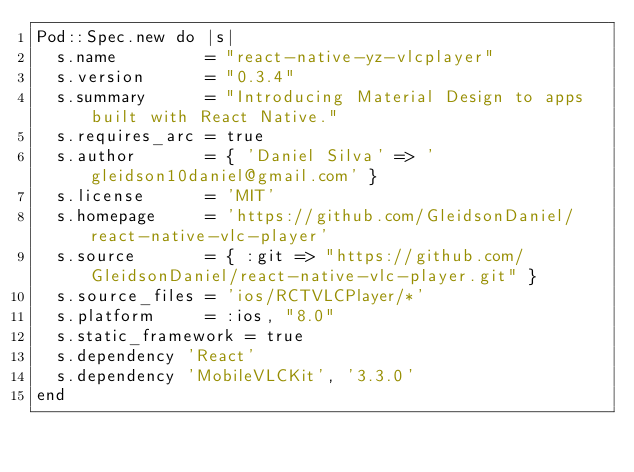<code> <loc_0><loc_0><loc_500><loc_500><_Ruby_>Pod::Spec.new do |s|
  s.name         = "react-native-yz-vlcplayer"
  s.version      = "0.3.4"
  s.summary      = "Introducing Material Design to apps built with React Native."
  s.requires_arc = true
  s.author       = { 'Daniel Silva' => 'gleidson10daniel@gmail.com' }
  s.license      = 'MIT'
  s.homepage     = 'https://github.com/GleidsonDaniel/react-native-vlc-player'
  s.source       = { :git => "https://github.com/GleidsonDaniel/react-native-vlc-player.git" }
  s.source_files = 'ios/RCTVLCPlayer/*'
  s.platform     = :ios, "8.0"
  s.static_framework = true  
  s.dependency 'React'
  s.dependency 'MobileVLCKit', '3.3.0'
end
</code> 